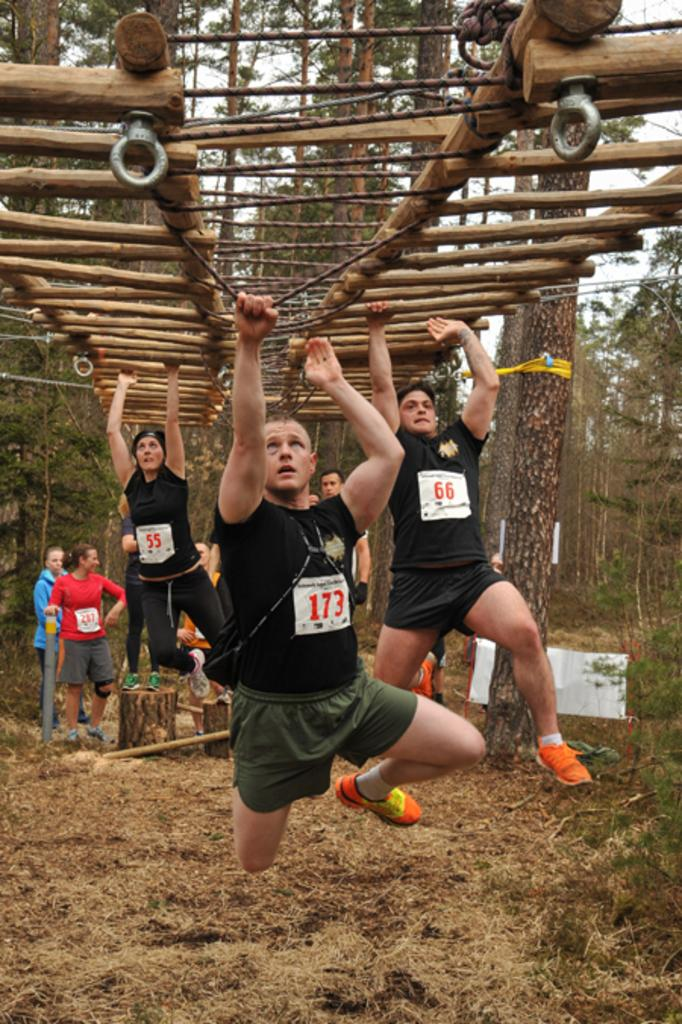<image>
Share a concise interpretation of the image provided. The men are doing a relay race and the leader is number 173. 